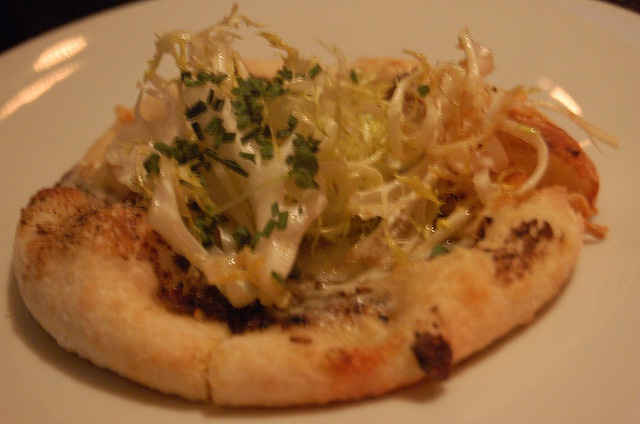Describe the objects in this image and their specific colors. I can see a pizza in black, brown, maroon, and tan tones in this image. 